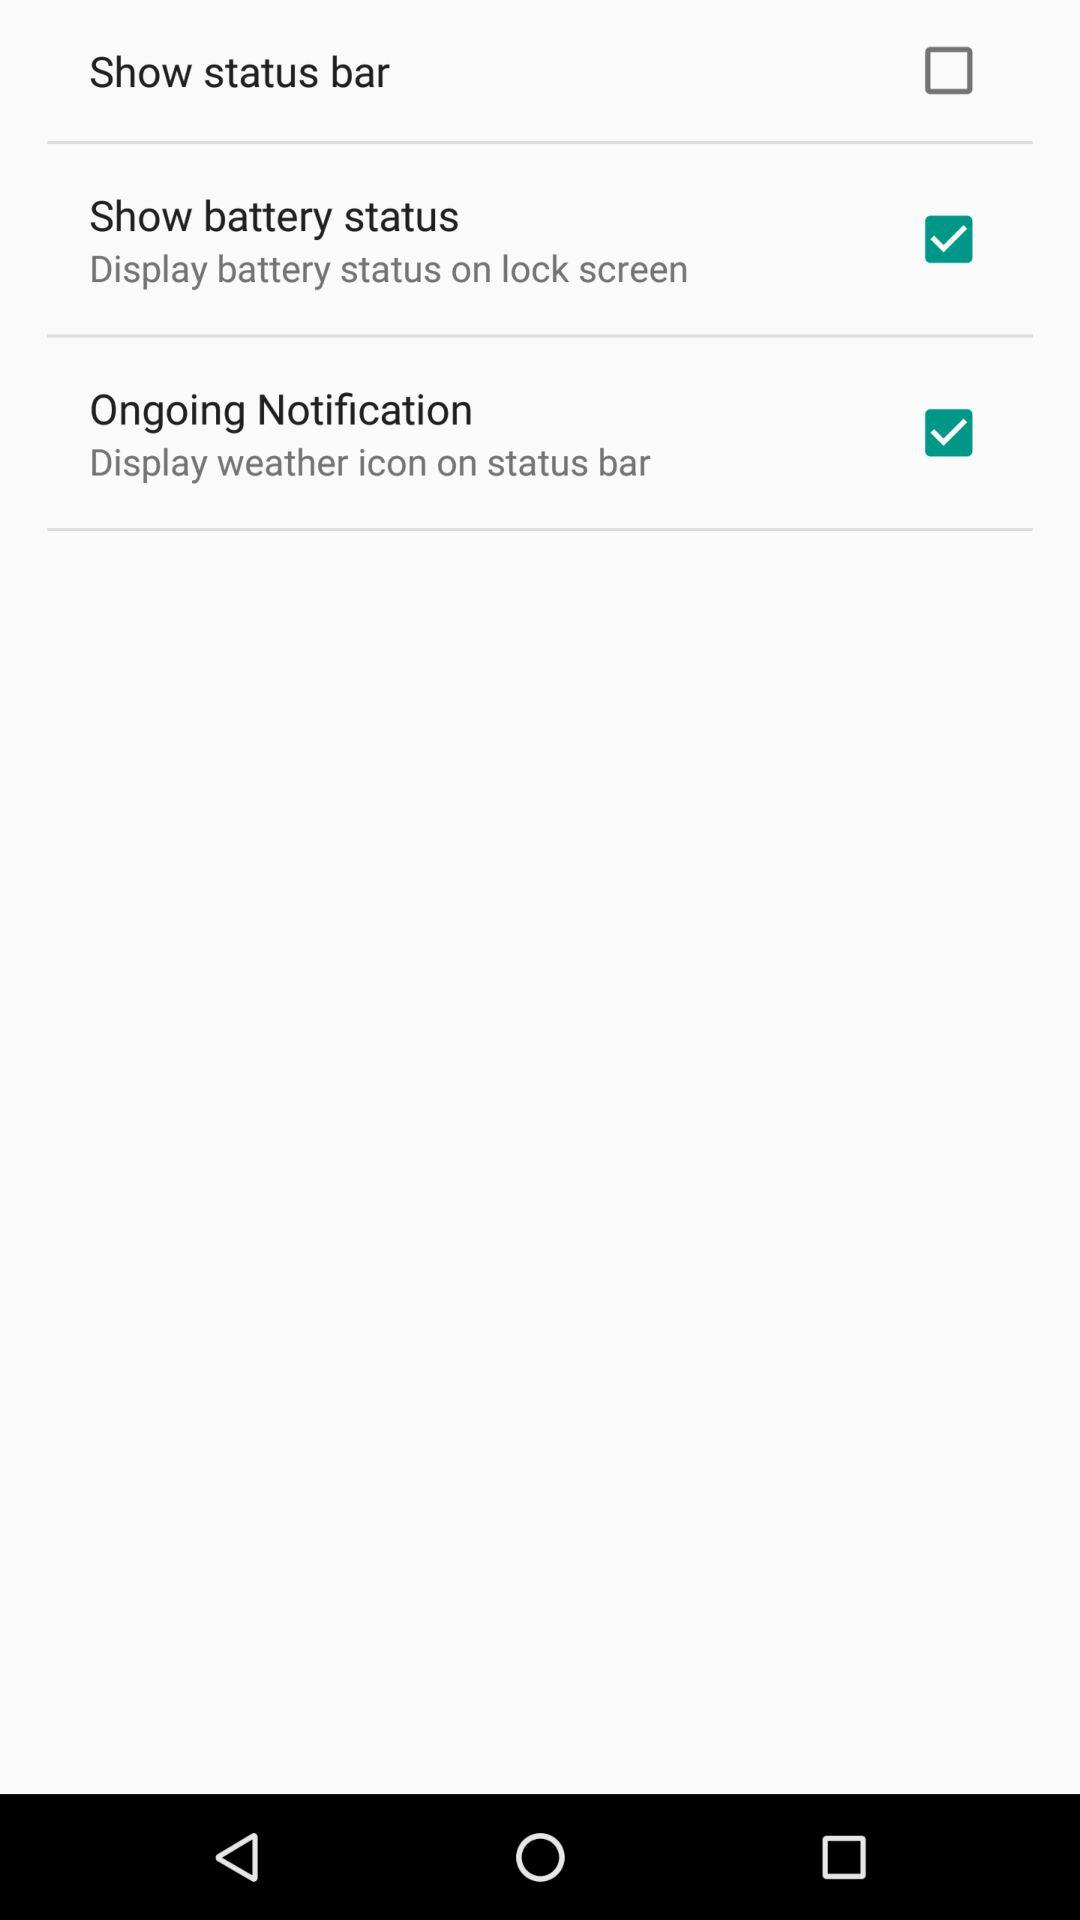What is the status of "Show battery status"? The status is "on". 